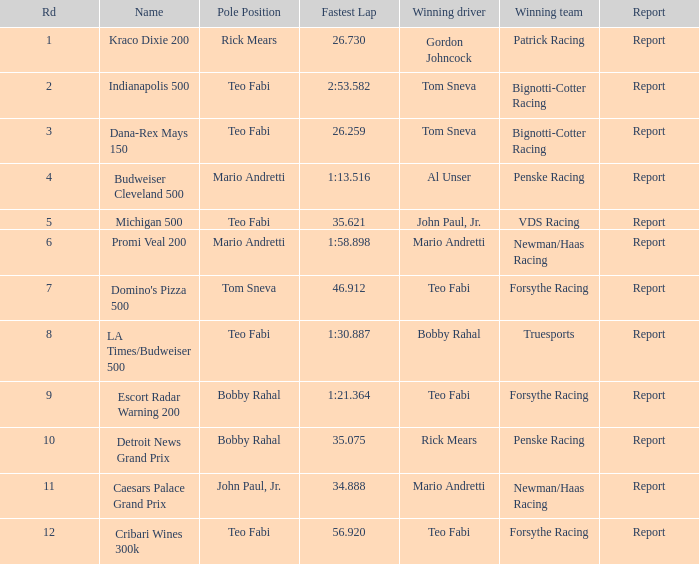Help me parse the entirety of this table. {'header': ['Rd', 'Name', 'Pole Position', 'Fastest Lap', 'Winning driver', 'Winning team', 'Report'], 'rows': [['1', 'Kraco Dixie 200', 'Rick Mears', '26.730', 'Gordon Johncock', 'Patrick Racing', 'Report'], ['2', 'Indianapolis 500', 'Teo Fabi', '2:53.582', 'Tom Sneva', 'Bignotti-Cotter Racing', 'Report'], ['3', 'Dana-Rex Mays 150', 'Teo Fabi', '26.259', 'Tom Sneva', 'Bignotti-Cotter Racing', 'Report'], ['4', 'Budweiser Cleveland 500', 'Mario Andretti', '1:13.516', 'Al Unser', 'Penske Racing', 'Report'], ['5', 'Michigan 500', 'Teo Fabi', '35.621', 'John Paul, Jr.', 'VDS Racing', 'Report'], ['6', 'Promi Veal 200', 'Mario Andretti', '1:58.898', 'Mario Andretti', 'Newman/Haas Racing', 'Report'], ['7', "Domino's Pizza 500", 'Tom Sneva', '46.912', 'Teo Fabi', 'Forsythe Racing', 'Report'], ['8', 'LA Times/Budweiser 500', 'Teo Fabi', '1:30.887', 'Bobby Rahal', 'Truesports', 'Report'], ['9', 'Escort Radar Warning 200', 'Bobby Rahal', '1:21.364', 'Teo Fabi', 'Forsythe Racing', 'Report'], ['10', 'Detroit News Grand Prix', 'Bobby Rahal', '35.075', 'Rick Mears', 'Penske Racing', 'Report'], ['11', 'Caesars Palace Grand Prix', 'John Paul, Jr.', '34.888', 'Mario Andretti', 'Newman/Haas Racing', 'Report'], ['12', 'Cribari Wines 300k', 'Teo Fabi', '56.920', 'Teo Fabi', 'Forsythe Racing', 'Report']]} Which teams won when Bobby Rahal was their winning driver? Truesports. 